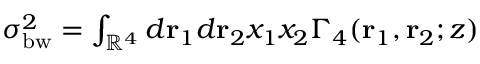Convert formula to latex. <formula><loc_0><loc_0><loc_500><loc_500>\begin{array} { r } { \sigma _ { b w } ^ { 2 } = \int _ { \mathbb { R } ^ { 4 } } d r _ { 1 } d r _ { 2 } x _ { 1 } x _ { 2 } \Gamma _ { 4 } ( r _ { 1 } , r _ { 2 } ; z ) } \end{array}</formula> 